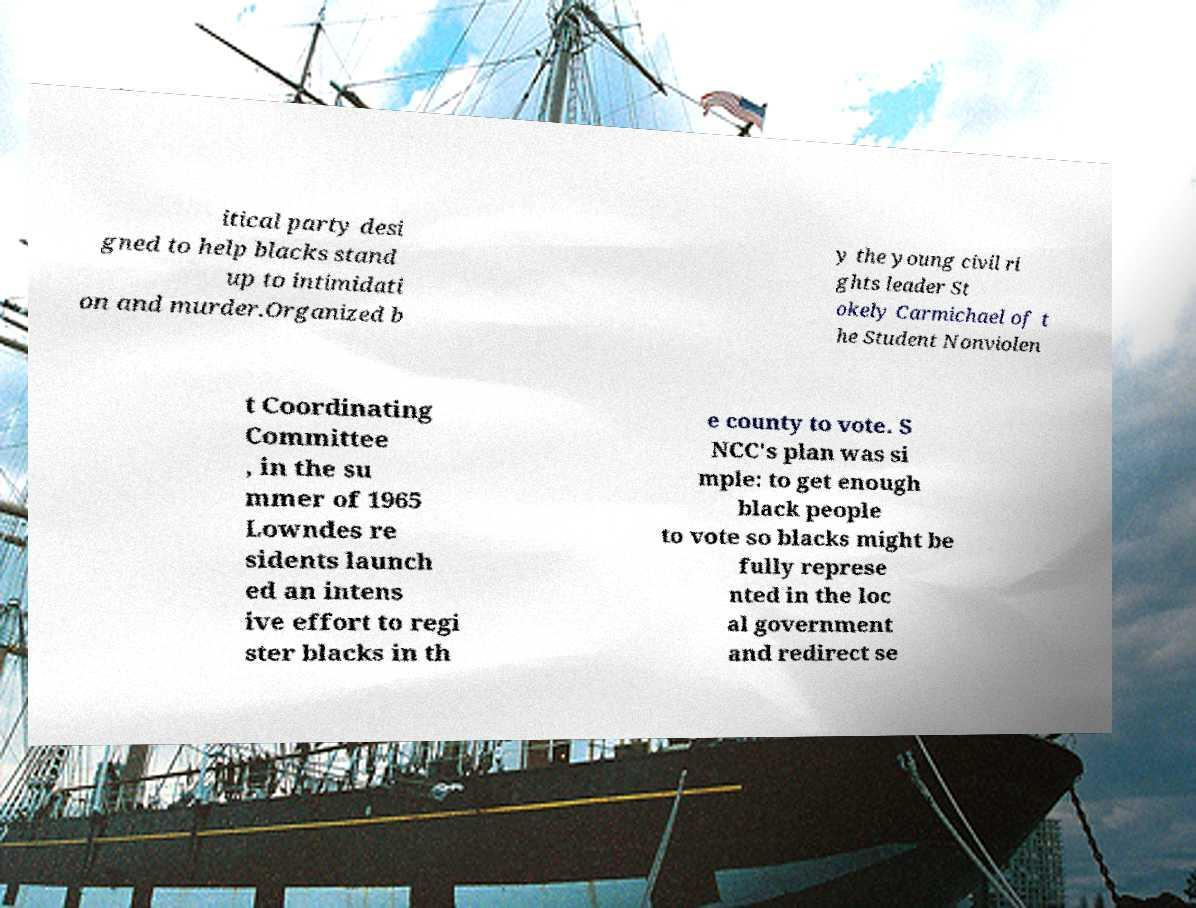Can you accurately transcribe the text from the provided image for me? itical party desi gned to help blacks stand up to intimidati on and murder.Organized b y the young civil ri ghts leader St okely Carmichael of t he Student Nonviolen t Coordinating Committee , in the su mmer of 1965 Lowndes re sidents launch ed an intens ive effort to regi ster blacks in th e county to vote. S NCC's plan was si mple: to get enough black people to vote so blacks might be fully represe nted in the loc al government and redirect se 